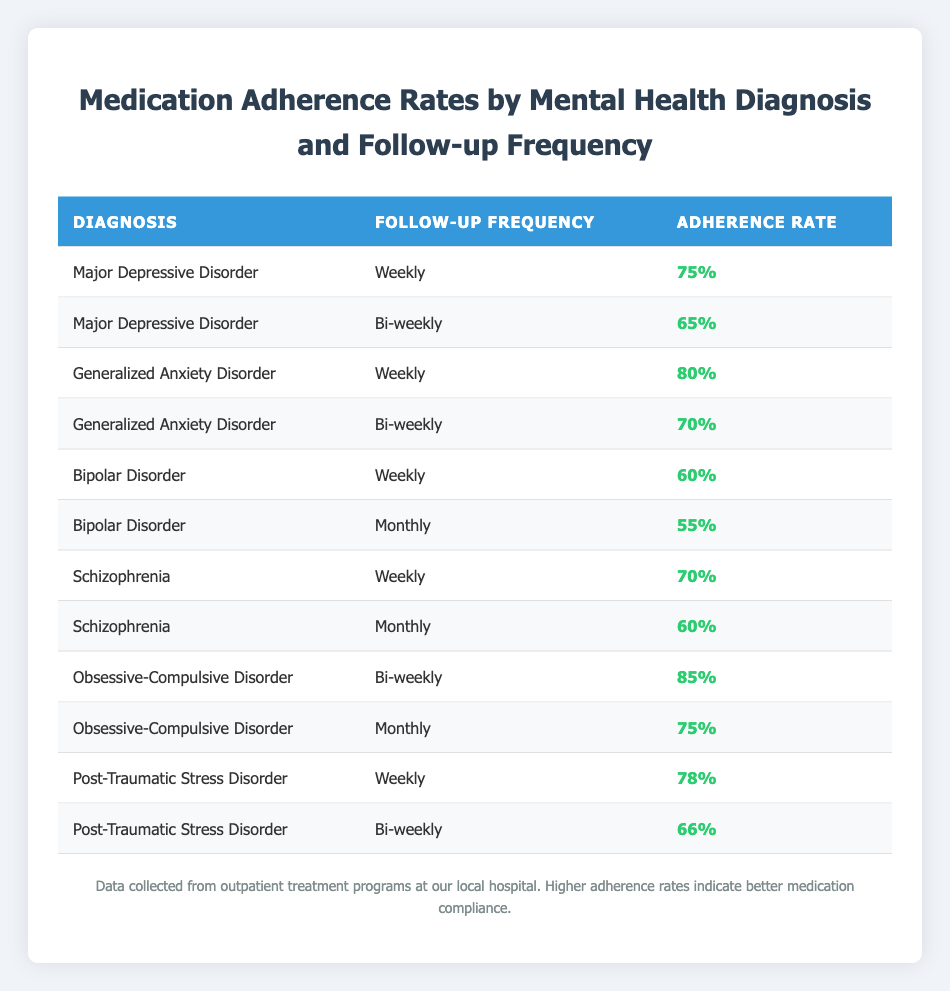What is the adherence rate for Generalized Anxiety Disorder for weekly follow-up? Looking at the table, the row corresponding to Generalized Anxiety Disorder and a weekly follow-up shows an adherence rate of 80%.
Answer: 80% Which diagnosis has the highest medication adherence rate for bi-weekly follow-up? The bi-weekly follow-up rates show that Obsessive-Compulsive Disorder has the highest adherence rate at 85%, compared to 70% for Generalized Anxiety Disorder and 66% for Post-Traumatic Stress Disorder.
Answer: Obsessive-Compulsive Disorder Is the adherence rate for Bipolar Disorder lower than 60% for monthly follow-up? Referencing the table, Bipolar Disorder has a monthly adherence rate of 55%, which is indeed lower than 60%.
Answer: Yes What is the average adherence rate for follow-ups with a monthly frequency? The monthly follow-up adherence rates are 55% for Bipolar Disorder, 60% for Schizophrenia, and 75% for Obsessive-Compulsive Disorder. Summing these gives 55 + 60 + 75 = 190, and there are 3 data points, so the average is 190/3 = 63.33%.
Answer: 63.33% Which diagnosis has the lowest adherence rate among all follow-up frequencies? The table lists Bipolar Disorder with a monthly follow-up adherence rate of 55%, which is the lowest when compared to others in their respective follow-ups.
Answer: Bipolar Disorder Does the adherence rate for Major Depressive Disorder decrease when the follow-up frequency changes from weekly to bi-weekly? The table shows that Major Depressive Disorder has a weekly adherence rate of 75% and a bi-weekly rate of 65%. Since 65% is lower than 75%, the answer is yes.
Answer: Yes What is the difference in adherence rates between Obsessive-Compulsive Disorder for bi-weekly and monthly follow-up? The adherence rate for Obsessive-Compulsive Disorder is 85% for bi-weekly follow-up and 75% for monthly follow-up. The difference is 85 - 75 = 10%.
Answer: 10% For which diagnosis does the weekly follow-up have a higher adherence rate than the bi-weekly follow-up? Looking at the table, Generalized Anxiety Disorder (80% vs 70%) and Post-Traumatic Stress Disorder (78% vs 66%) both have higher adherence rates for weekly follow-ups compared to bi-weekly follow-ups.
Answer: Generalized Anxiety Disorder and Post-Traumatic Stress Disorder 